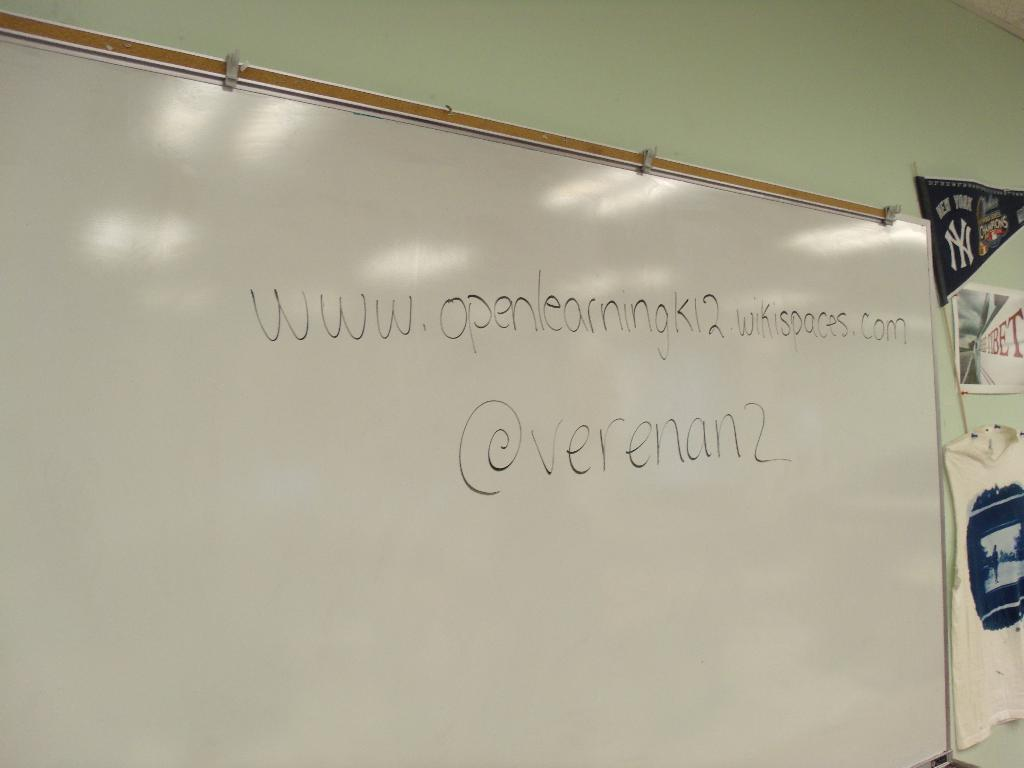<image>
Create a compact narrative representing the image presented. A website for openlearningk12 is written on the white board. 